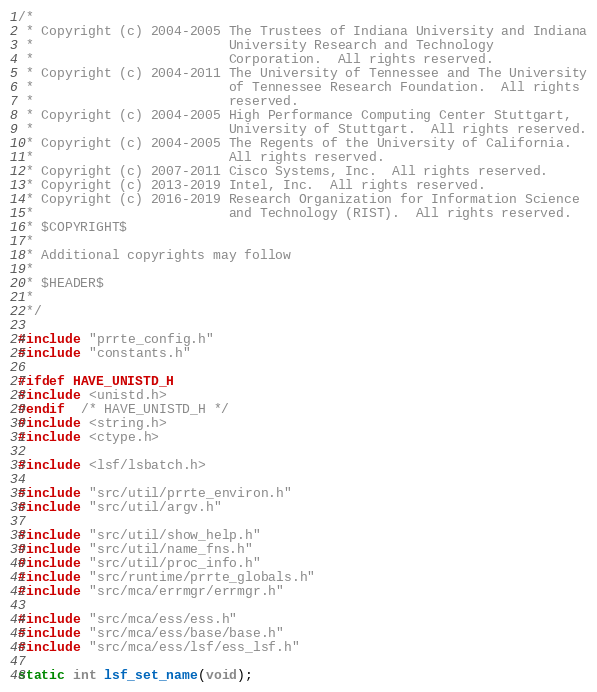Convert code to text. <code><loc_0><loc_0><loc_500><loc_500><_C_>/*
 * Copyright (c) 2004-2005 The Trustees of Indiana University and Indiana
 *                         University Research and Technology
 *                         Corporation.  All rights reserved.
 * Copyright (c) 2004-2011 The University of Tennessee and The University
 *                         of Tennessee Research Foundation.  All rights
 *                         reserved.
 * Copyright (c) 2004-2005 High Performance Computing Center Stuttgart,
 *                         University of Stuttgart.  All rights reserved.
 * Copyright (c) 2004-2005 The Regents of the University of California.
 *                         All rights reserved.
 * Copyright (c) 2007-2011 Cisco Systems, Inc.  All rights reserved.
 * Copyright (c) 2013-2019 Intel, Inc.  All rights reserved.
 * Copyright (c) 2016-2019 Research Organization for Information Science
 *                         and Technology (RIST).  All rights reserved.
 * $COPYRIGHT$
 *
 * Additional copyrights may follow
 *
 * $HEADER$
 *
 */

#include "prrte_config.h"
#include "constants.h"

#ifdef HAVE_UNISTD_H
#include <unistd.h>
#endif  /* HAVE_UNISTD_H */
#include <string.h>
#include <ctype.h>

#include <lsf/lsbatch.h>

#include "src/util/prrte_environ.h"
#include "src/util/argv.h"

#include "src/util/show_help.h"
#include "src/util/name_fns.h"
#include "src/util/proc_info.h"
#include "src/runtime/prrte_globals.h"
#include "src/mca/errmgr/errmgr.h"

#include "src/mca/ess/ess.h"
#include "src/mca/ess/base/base.h"
#include "src/mca/ess/lsf/ess_lsf.h"

static int lsf_set_name(void);
</code> 